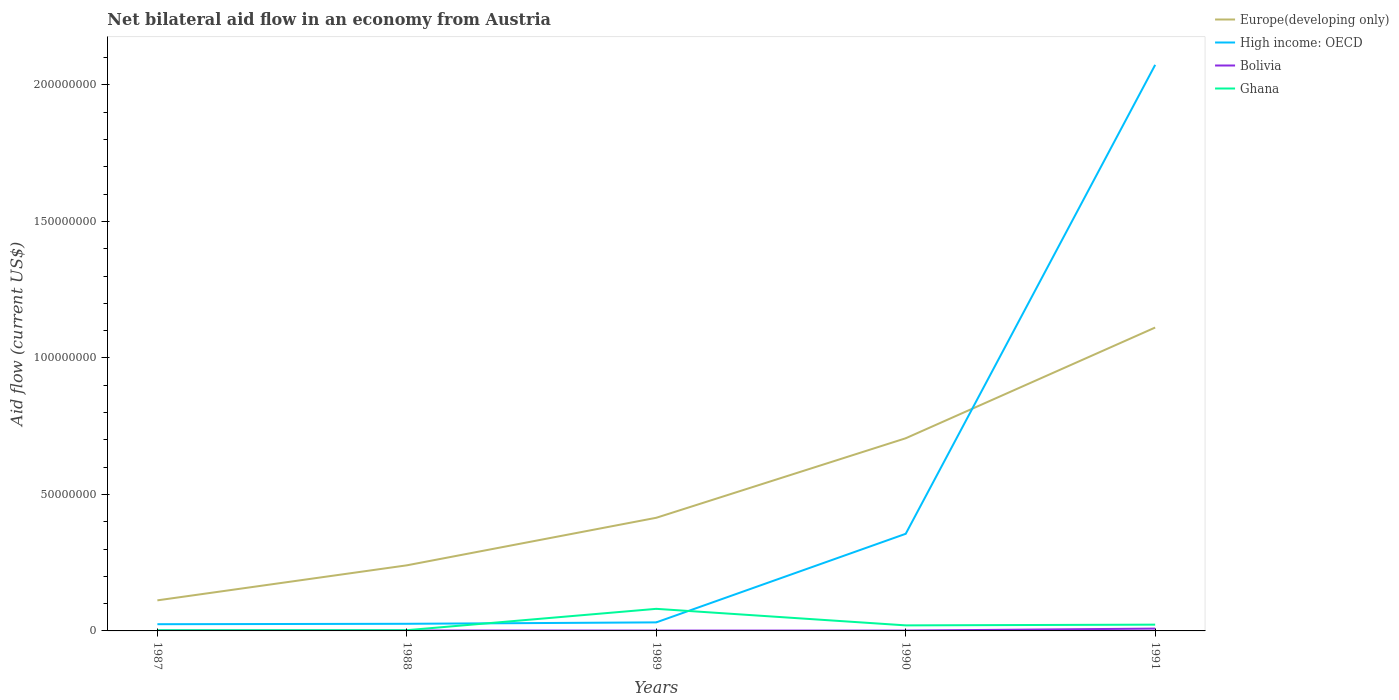Does the line corresponding to Ghana intersect with the line corresponding to Europe(developing only)?
Ensure brevity in your answer.  No. Is the number of lines equal to the number of legend labels?
Provide a succinct answer. Yes. Across all years, what is the maximum net bilateral aid flow in Bolivia?
Provide a succinct answer. 1.30e+05. In which year was the net bilateral aid flow in Bolivia maximum?
Keep it short and to the point. 1989. What is the total net bilateral aid flow in Bolivia in the graph?
Make the answer very short. -7.20e+05. What is the difference between the highest and the second highest net bilateral aid flow in Europe(developing only)?
Your answer should be very brief. 9.99e+07. How many lines are there?
Ensure brevity in your answer.  4. How many years are there in the graph?
Keep it short and to the point. 5. Does the graph contain any zero values?
Give a very brief answer. No. Does the graph contain grids?
Your answer should be compact. No. Where does the legend appear in the graph?
Give a very brief answer. Top right. How many legend labels are there?
Your answer should be compact. 4. How are the legend labels stacked?
Your answer should be very brief. Vertical. What is the title of the graph?
Your response must be concise. Net bilateral aid flow in an economy from Austria. Does "Russian Federation" appear as one of the legend labels in the graph?
Make the answer very short. No. What is the label or title of the X-axis?
Your answer should be very brief. Years. What is the Aid flow (current US$) of Europe(developing only) in 1987?
Make the answer very short. 1.12e+07. What is the Aid flow (current US$) in High income: OECD in 1987?
Provide a succinct answer. 2.46e+06. What is the Aid flow (current US$) in Europe(developing only) in 1988?
Offer a terse response. 2.40e+07. What is the Aid flow (current US$) in High income: OECD in 1988?
Your answer should be compact. 2.61e+06. What is the Aid flow (current US$) of Bolivia in 1988?
Provide a succinct answer. 1.60e+05. What is the Aid flow (current US$) in Europe(developing only) in 1989?
Provide a succinct answer. 4.14e+07. What is the Aid flow (current US$) of High income: OECD in 1989?
Give a very brief answer. 3.13e+06. What is the Aid flow (current US$) of Bolivia in 1989?
Your answer should be compact. 1.30e+05. What is the Aid flow (current US$) of Ghana in 1989?
Your response must be concise. 8.09e+06. What is the Aid flow (current US$) of Europe(developing only) in 1990?
Keep it short and to the point. 7.06e+07. What is the Aid flow (current US$) of High income: OECD in 1990?
Keep it short and to the point. 3.56e+07. What is the Aid flow (current US$) of Bolivia in 1990?
Keep it short and to the point. 1.30e+05. What is the Aid flow (current US$) in Ghana in 1990?
Your answer should be very brief. 2.03e+06. What is the Aid flow (current US$) in Europe(developing only) in 1991?
Give a very brief answer. 1.11e+08. What is the Aid flow (current US$) in High income: OECD in 1991?
Your answer should be very brief. 2.07e+08. What is the Aid flow (current US$) in Bolivia in 1991?
Provide a short and direct response. 8.50e+05. What is the Aid flow (current US$) of Ghana in 1991?
Keep it short and to the point. 2.30e+06. Across all years, what is the maximum Aid flow (current US$) in Europe(developing only)?
Offer a terse response. 1.11e+08. Across all years, what is the maximum Aid flow (current US$) of High income: OECD?
Provide a short and direct response. 2.07e+08. Across all years, what is the maximum Aid flow (current US$) of Bolivia?
Ensure brevity in your answer.  8.50e+05. Across all years, what is the maximum Aid flow (current US$) in Ghana?
Make the answer very short. 8.09e+06. Across all years, what is the minimum Aid flow (current US$) in Europe(developing only)?
Provide a short and direct response. 1.12e+07. Across all years, what is the minimum Aid flow (current US$) of High income: OECD?
Make the answer very short. 2.46e+06. What is the total Aid flow (current US$) of Europe(developing only) in the graph?
Your answer should be compact. 2.58e+08. What is the total Aid flow (current US$) of High income: OECD in the graph?
Your response must be concise. 2.51e+08. What is the total Aid flow (current US$) of Bolivia in the graph?
Give a very brief answer. 1.41e+06. What is the total Aid flow (current US$) of Ghana in the graph?
Give a very brief answer. 1.29e+07. What is the difference between the Aid flow (current US$) of Europe(developing only) in 1987 and that in 1988?
Provide a succinct answer. -1.28e+07. What is the difference between the Aid flow (current US$) of Europe(developing only) in 1987 and that in 1989?
Offer a terse response. -3.02e+07. What is the difference between the Aid flow (current US$) in High income: OECD in 1987 and that in 1989?
Your response must be concise. -6.70e+05. What is the difference between the Aid flow (current US$) of Bolivia in 1987 and that in 1989?
Make the answer very short. 10000. What is the difference between the Aid flow (current US$) in Ghana in 1987 and that in 1989?
Your answer should be compact. -7.84e+06. What is the difference between the Aid flow (current US$) in Europe(developing only) in 1987 and that in 1990?
Make the answer very short. -5.94e+07. What is the difference between the Aid flow (current US$) of High income: OECD in 1987 and that in 1990?
Offer a very short reply. -3.31e+07. What is the difference between the Aid flow (current US$) of Bolivia in 1987 and that in 1990?
Make the answer very short. 10000. What is the difference between the Aid flow (current US$) in Ghana in 1987 and that in 1990?
Give a very brief answer. -1.78e+06. What is the difference between the Aid flow (current US$) of Europe(developing only) in 1987 and that in 1991?
Your answer should be very brief. -9.99e+07. What is the difference between the Aid flow (current US$) in High income: OECD in 1987 and that in 1991?
Keep it short and to the point. -2.05e+08. What is the difference between the Aid flow (current US$) in Bolivia in 1987 and that in 1991?
Offer a terse response. -7.10e+05. What is the difference between the Aid flow (current US$) of Ghana in 1987 and that in 1991?
Your response must be concise. -2.05e+06. What is the difference between the Aid flow (current US$) of Europe(developing only) in 1988 and that in 1989?
Your response must be concise. -1.74e+07. What is the difference between the Aid flow (current US$) in High income: OECD in 1988 and that in 1989?
Provide a succinct answer. -5.20e+05. What is the difference between the Aid flow (current US$) of Bolivia in 1988 and that in 1989?
Your answer should be compact. 3.00e+04. What is the difference between the Aid flow (current US$) of Ghana in 1988 and that in 1989?
Your response must be concise. -7.82e+06. What is the difference between the Aid flow (current US$) in Europe(developing only) in 1988 and that in 1990?
Keep it short and to the point. -4.66e+07. What is the difference between the Aid flow (current US$) in High income: OECD in 1988 and that in 1990?
Make the answer very short. -3.30e+07. What is the difference between the Aid flow (current US$) in Ghana in 1988 and that in 1990?
Offer a very short reply. -1.76e+06. What is the difference between the Aid flow (current US$) of Europe(developing only) in 1988 and that in 1991?
Your response must be concise. -8.71e+07. What is the difference between the Aid flow (current US$) in High income: OECD in 1988 and that in 1991?
Offer a terse response. -2.05e+08. What is the difference between the Aid flow (current US$) in Bolivia in 1988 and that in 1991?
Provide a short and direct response. -6.90e+05. What is the difference between the Aid flow (current US$) in Ghana in 1988 and that in 1991?
Offer a terse response. -2.03e+06. What is the difference between the Aid flow (current US$) of Europe(developing only) in 1989 and that in 1990?
Give a very brief answer. -2.91e+07. What is the difference between the Aid flow (current US$) of High income: OECD in 1989 and that in 1990?
Ensure brevity in your answer.  -3.24e+07. What is the difference between the Aid flow (current US$) of Ghana in 1989 and that in 1990?
Your answer should be very brief. 6.06e+06. What is the difference between the Aid flow (current US$) of Europe(developing only) in 1989 and that in 1991?
Ensure brevity in your answer.  -6.97e+07. What is the difference between the Aid flow (current US$) in High income: OECD in 1989 and that in 1991?
Offer a terse response. -2.04e+08. What is the difference between the Aid flow (current US$) of Bolivia in 1989 and that in 1991?
Offer a terse response. -7.20e+05. What is the difference between the Aid flow (current US$) in Ghana in 1989 and that in 1991?
Your answer should be compact. 5.79e+06. What is the difference between the Aid flow (current US$) in Europe(developing only) in 1990 and that in 1991?
Your response must be concise. -4.06e+07. What is the difference between the Aid flow (current US$) in High income: OECD in 1990 and that in 1991?
Give a very brief answer. -1.72e+08. What is the difference between the Aid flow (current US$) of Bolivia in 1990 and that in 1991?
Give a very brief answer. -7.20e+05. What is the difference between the Aid flow (current US$) in Europe(developing only) in 1987 and the Aid flow (current US$) in High income: OECD in 1988?
Offer a terse response. 8.59e+06. What is the difference between the Aid flow (current US$) of Europe(developing only) in 1987 and the Aid flow (current US$) of Bolivia in 1988?
Keep it short and to the point. 1.10e+07. What is the difference between the Aid flow (current US$) in Europe(developing only) in 1987 and the Aid flow (current US$) in Ghana in 1988?
Provide a short and direct response. 1.09e+07. What is the difference between the Aid flow (current US$) in High income: OECD in 1987 and the Aid flow (current US$) in Bolivia in 1988?
Your response must be concise. 2.30e+06. What is the difference between the Aid flow (current US$) of High income: OECD in 1987 and the Aid flow (current US$) of Ghana in 1988?
Provide a short and direct response. 2.19e+06. What is the difference between the Aid flow (current US$) of Bolivia in 1987 and the Aid flow (current US$) of Ghana in 1988?
Provide a short and direct response. -1.30e+05. What is the difference between the Aid flow (current US$) in Europe(developing only) in 1987 and the Aid flow (current US$) in High income: OECD in 1989?
Provide a short and direct response. 8.07e+06. What is the difference between the Aid flow (current US$) of Europe(developing only) in 1987 and the Aid flow (current US$) of Bolivia in 1989?
Offer a very short reply. 1.11e+07. What is the difference between the Aid flow (current US$) of Europe(developing only) in 1987 and the Aid flow (current US$) of Ghana in 1989?
Give a very brief answer. 3.11e+06. What is the difference between the Aid flow (current US$) in High income: OECD in 1987 and the Aid flow (current US$) in Bolivia in 1989?
Ensure brevity in your answer.  2.33e+06. What is the difference between the Aid flow (current US$) in High income: OECD in 1987 and the Aid flow (current US$) in Ghana in 1989?
Your response must be concise. -5.63e+06. What is the difference between the Aid flow (current US$) of Bolivia in 1987 and the Aid flow (current US$) of Ghana in 1989?
Your answer should be compact. -7.95e+06. What is the difference between the Aid flow (current US$) in Europe(developing only) in 1987 and the Aid flow (current US$) in High income: OECD in 1990?
Offer a terse response. -2.44e+07. What is the difference between the Aid flow (current US$) of Europe(developing only) in 1987 and the Aid flow (current US$) of Bolivia in 1990?
Your answer should be compact. 1.11e+07. What is the difference between the Aid flow (current US$) in Europe(developing only) in 1987 and the Aid flow (current US$) in Ghana in 1990?
Ensure brevity in your answer.  9.17e+06. What is the difference between the Aid flow (current US$) of High income: OECD in 1987 and the Aid flow (current US$) of Bolivia in 1990?
Make the answer very short. 2.33e+06. What is the difference between the Aid flow (current US$) of High income: OECD in 1987 and the Aid flow (current US$) of Ghana in 1990?
Provide a succinct answer. 4.30e+05. What is the difference between the Aid flow (current US$) of Bolivia in 1987 and the Aid flow (current US$) of Ghana in 1990?
Provide a succinct answer. -1.89e+06. What is the difference between the Aid flow (current US$) of Europe(developing only) in 1987 and the Aid flow (current US$) of High income: OECD in 1991?
Your answer should be very brief. -1.96e+08. What is the difference between the Aid flow (current US$) of Europe(developing only) in 1987 and the Aid flow (current US$) of Bolivia in 1991?
Keep it short and to the point. 1.04e+07. What is the difference between the Aid flow (current US$) of Europe(developing only) in 1987 and the Aid flow (current US$) of Ghana in 1991?
Your answer should be very brief. 8.90e+06. What is the difference between the Aid flow (current US$) of High income: OECD in 1987 and the Aid flow (current US$) of Bolivia in 1991?
Ensure brevity in your answer.  1.61e+06. What is the difference between the Aid flow (current US$) of Bolivia in 1987 and the Aid flow (current US$) of Ghana in 1991?
Your response must be concise. -2.16e+06. What is the difference between the Aid flow (current US$) in Europe(developing only) in 1988 and the Aid flow (current US$) in High income: OECD in 1989?
Provide a short and direct response. 2.09e+07. What is the difference between the Aid flow (current US$) in Europe(developing only) in 1988 and the Aid flow (current US$) in Bolivia in 1989?
Offer a terse response. 2.39e+07. What is the difference between the Aid flow (current US$) of Europe(developing only) in 1988 and the Aid flow (current US$) of Ghana in 1989?
Keep it short and to the point. 1.59e+07. What is the difference between the Aid flow (current US$) of High income: OECD in 1988 and the Aid flow (current US$) of Bolivia in 1989?
Your response must be concise. 2.48e+06. What is the difference between the Aid flow (current US$) in High income: OECD in 1988 and the Aid flow (current US$) in Ghana in 1989?
Keep it short and to the point. -5.48e+06. What is the difference between the Aid flow (current US$) in Bolivia in 1988 and the Aid flow (current US$) in Ghana in 1989?
Offer a very short reply. -7.93e+06. What is the difference between the Aid flow (current US$) in Europe(developing only) in 1988 and the Aid flow (current US$) in High income: OECD in 1990?
Provide a succinct answer. -1.16e+07. What is the difference between the Aid flow (current US$) in Europe(developing only) in 1988 and the Aid flow (current US$) in Bolivia in 1990?
Provide a succinct answer. 2.39e+07. What is the difference between the Aid flow (current US$) in Europe(developing only) in 1988 and the Aid flow (current US$) in Ghana in 1990?
Make the answer very short. 2.20e+07. What is the difference between the Aid flow (current US$) of High income: OECD in 1988 and the Aid flow (current US$) of Bolivia in 1990?
Make the answer very short. 2.48e+06. What is the difference between the Aid flow (current US$) in High income: OECD in 1988 and the Aid flow (current US$) in Ghana in 1990?
Give a very brief answer. 5.80e+05. What is the difference between the Aid flow (current US$) of Bolivia in 1988 and the Aid flow (current US$) of Ghana in 1990?
Your answer should be very brief. -1.87e+06. What is the difference between the Aid flow (current US$) in Europe(developing only) in 1988 and the Aid flow (current US$) in High income: OECD in 1991?
Your response must be concise. -1.83e+08. What is the difference between the Aid flow (current US$) of Europe(developing only) in 1988 and the Aid flow (current US$) of Bolivia in 1991?
Your response must be concise. 2.32e+07. What is the difference between the Aid flow (current US$) of Europe(developing only) in 1988 and the Aid flow (current US$) of Ghana in 1991?
Your response must be concise. 2.17e+07. What is the difference between the Aid flow (current US$) in High income: OECD in 1988 and the Aid flow (current US$) in Bolivia in 1991?
Your response must be concise. 1.76e+06. What is the difference between the Aid flow (current US$) of High income: OECD in 1988 and the Aid flow (current US$) of Ghana in 1991?
Keep it short and to the point. 3.10e+05. What is the difference between the Aid flow (current US$) in Bolivia in 1988 and the Aid flow (current US$) in Ghana in 1991?
Provide a succinct answer. -2.14e+06. What is the difference between the Aid flow (current US$) of Europe(developing only) in 1989 and the Aid flow (current US$) of High income: OECD in 1990?
Provide a succinct answer. 5.87e+06. What is the difference between the Aid flow (current US$) in Europe(developing only) in 1989 and the Aid flow (current US$) in Bolivia in 1990?
Offer a very short reply. 4.13e+07. What is the difference between the Aid flow (current US$) of Europe(developing only) in 1989 and the Aid flow (current US$) of Ghana in 1990?
Provide a short and direct response. 3.94e+07. What is the difference between the Aid flow (current US$) in High income: OECD in 1989 and the Aid flow (current US$) in Bolivia in 1990?
Offer a very short reply. 3.00e+06. What is the difference between the Aid flow (current US$) of High income: OECD in 1989 and the Aid flow (current US$) of Ghana in 1990?
Keep it short and to the point. 1.10e+06. What is the difference between the Aid flow (current US$) of Bolivia in 1989 and the Aid flow (current US$) of Ghana in 1990?
Keep it short and to the point. -1.90e+06. What is the difference between the Aid flow (current US$) of Europe(developing only) in 1989 and the Aid flow (current US$) of High income: OECD in 1991?
Your answer should be compact. -1.66e+08. What is the difference between the Aid flow (current US$) of Europe(developing only) in 1989 and the Aid flow (current US$) of Bolivia in 1991?
Make the answer very short. 4.06e+07. What is the difference between the Aid flow (current US$) in Europe(developing only) in 1989 and the Aid flow (current US$) in Ghana in 1991?
Give a very brief answer. 3.92e+07. What is the difference between the Aid flow (current US$) of High income: OECD in 1989 and the Aid flow (current US$) of Bolivia in 1991?
Keep it short and to the point. 2.28e+06. What is the difference between the Aid flow (current US$) of High income: OECD in 1989 and the Aid flow (current US$) of Ghana in 1991?
Your response must be concise. 8.30e+05. What is the difference between the Aid flow (current US$) of Bolivia in 1989 and the Aid flow (current US$) of Ghana in 1991?
Provide a succinct answer. -2.17e+06. What is the difference between the Aid flow (current US$) of Europe(developing only) in 1990 and the Aid flow (current US$) of High income: OECD in 1991?
Keep it short and to the point. -1.37e+08. What is the difference between the Aid flow (current US$) of Europe(developing only) in 1990 and the Aid flow (current US$) of Bolivia in 1991?
Provide a short and direct response. 6.97e+07. What is the difference between the Aid flow (current US$) of Europe(developing only) in 1990 and the Aid flow (current US$) of Ghana in 1991?
Offer a terse response. 6.83e+07. What is the difference between the Aid flow (current US$) of High income: OECD in 1990 and the Aid flow (current US$) of Bolivia in 1991?
Your answer should be compact. 3.47e+07. What is the difference between the Aid flow (current US$) of High income: OECD in 1990 and the Aid flow (current US$) of Ghana in 1991?
Give a very brief answer. 3.33e+07. What is the difference between the Aid flow (current US$) in Bolivia in 1990 and the Aid flow (current US$) in Ghana in 1991?
Give a very brief answer. -2.17e+06. What is the average Aid flow (current US$) in Europe(developing only) per year?
Your response must be concise. 5.17e+07. What is the average Aid flow (current US$) in High income: OECD per year?
Offer a very short reply. 5.02e+07. What is the average Aid flow (current US$) of Bolivia per year?
Give a very brief answer. 2.82e+05. What is the average Aid flow (current US$) in Ghana per year?
Your answer should be very brief. 2.59e+06. In the year 1987, what is the difference between the Aid flow (current US$) of Europe(developing only) and Aid flow (current US$) of High income: OECD?
Your answer should be compact. 8.74e+06. In the year 1987, what is the difference between the Aid flow (current US$) of Europe(developing only) and Aid flow (current US$) of Bolivia?
Your answer should be compact. 1.11e+07. In the year 1987, what is the difference between the Aid flow (current US$) of Europe(developing only) and Aid flow (current US$) of Ghana?
Ensure brevity in your answer.  1.10e+07. In the year 1987, what is the difference between the Aid flow (current US$) in High income: OECD and Aid flow (current US$) in Bolivia?
Ensure brevity in your answer.  2.32e+06. In the year 1987, what is the difference between the Aid flow (current US$) in High income: OECD and Aid flow (current US$) in Ghana?
Your answer should be compact. 2.21e+06. In the year 1987, what is the difference between the Aid flow (current US$) of Bolivia and Aid flow (current US$) of Ghana?
Make the answer very short. -1.10e+05. In the year 1988, what is the difference between the Aid flow (current US$) of Europe(developing only) and Aid flow (current US$) of High income: OECD?
Ensure brevity in your answer.  2.14e+07. In the year 1988, what is the difference between the Aid flow (current US$) of Europe(developing only) and Aid flow (current US$) of Bolivia?
Provide a short and direct response. 2.39e+07. In the year 1988, what is the difference between the Aid flow (current US$) of Europe(developing only) and Aid flow (current US$) of Ghana?
Ensure brevity in your answer.  2.38e+07. In the year 1988, what is the difference between the Aid flow (current US$) of High income: OECD and Aid flow (current US$) of Bolivia?
Your answer should be very brief. 2.45e+06. In the year 1988, what is the difference between the Aid flow (current US$) in High income: OECD and Aid flow (current US$) in Ghana?
Provide a succinct answer. 2.34e+06. In the year 1988, what is the difference between the Aid flow (current US$) in Bolivia and Aid flow (current US$) in Ghana?
Your response must be concise. -1.10e+05. In the year 1989, what is the difference between the Aid flow (current US$) in Europe(developing only) and Aid flow (current US$) in High income: OECD?
Offer a terse response. 3.83e+07. In the year 1989, what is the difference between the Aid flow (current US$) of Europe(developing only) and Aid flow (current US$) of Bolivia?
Give a very brief answer. 4.13e+07. In the year 1989, what is the difference between the Aid flow (current US$) in Europe(developing only) and Aid flow (current US$) in Ghana?
Make the answer very short. 3.34e+07. In the year 1989, what is the difference between the Aid flow (current US$) of High income: OECD and Aid flow (current US$) of Ghana?
Make the answer very short. -4.96e+06. In the year 1989, what is the difference between the Aid flow (current US$) in Bolivia and Aid flow (current US$) in Ghana?
Keep it short and to the point. -7.96e+06. In the year 1990, what is the difference between the Aid flow (current US$) in Europe(developing only) and Aid flow (current US$) in High income: OECD?
Provide a succinct answer. 3.50e+07. In the year 1990, what is the difference between the Aid flow (current US$) of Europe(developing only) and Aid flow (current US$) of Bolivia?
Make the answer very short. 7.04e+07. In the year 1990, what is the difference between the Aid flow (current US$) in Europe(developing only) and Aid flow (current US$) in Ghana?
Make the answer very short. 6.86e+07. In the year 1990, what is the difference between the Aid flow (current US$) in High income: OECD and Aid flow (current US$) in Bolivia?
Make the answer very short. 3.54e+07. In the year 1990, what is the difference between the Aid flow (current US$) of High income: OECD and Aid flow (current US$) of Ghana?
Offer a terse response. 3.36e+07. In the year 1990, what is the difference between the Aid flow (current US$) of Bolivia and Aid flow (current US$) of Ghana?
Your answer should be very brief. -1.90e+06. In the year 1991, what is the difference between the Aid flow (current US$) of Europe(developing only) and Aid flow (current US$) of High income: OECD?
Give a very brief answer. -9.62e+07. In the year 1991, what is the difference between the Aid flow (current US$) in Europe(developing only) and Aid flow (current US$) in Bolivia?
Provide a succinct answer. 1.10e+08. In the year 1991, what is the difference between the Aid flow (current US$) in Europe(developing only) and Aid flow (current US$) in Ghana?
Ensure brevity in your answer.  1.09e+08. In the year 1991, what is the difference between the Aid flow (current US$) of High income: OECD and Aid flow (current US$) of Bolivia?
Provide a short and direct response. 2.07e+08. In the year 1991, what is the difference between the Aid flow (current US$) of High income: OECD and Aid flow (current US$) of Ghana?
Ensure brevity in your answer.  2.05e+08. In the year 1991, what is the difference between the Aid flow (current US$) in Bolivia and Aid flow (current US$) in Ghana?
Your answer should be compact. -1.45e+06. What is the ratio of the Aid flow (current US$) in Europe(developing only) in 1987 to that in 1988?
Ensure brevity in your answer.  0.47. What is the ratio of the Aid flow (current US$) in High income: OECD in 1987 to that in 1988?
Provide a succinct answer. 0.94. What is the ratio of the Aid flow (current US$) of Ghana in 1987 to that in 1988?
Offer a terse response. 0.93. What is the ratio of the Aid flow (current US$) of Europe(developing only) in 1987 to that in 1989?
Offer a terse response. 0.27. What is the ratio of the Aid flow (current US$) in High income: OECD in 1987 to that in 1989?
Offer a terse response. 0.79. What is the ratio of the Aid flow (current US$) of Ghana in 1987 to that in 1989?
Ensure brevity in your answer.  0.03. What is the ratio of the Aid flow (current US$) in Europe(developing only) in 1987 to that in 1990?
Keep it short and to the point. 0.16. What is the ratio of the Aid flow (current US$) of High income: OECD in 1987 to that in 1990?
Your answer should be very brief. 0.07. What is the ratio of the Aid flow (current US$) of Ghana in 1987 to that in 1990?
Give a very brief answer. 0.12. What is the ratio of the Aid flow (current US$) in Europe(developing only) in 1987 to that in 1991?
Your answer should be very brief. 0.1. What is the ratio of the Aid flow (current US$) of High income: OECD in 1987 to that in 1991?
Make the answer very short. 0.01. What is the ratio of the Aid flow (current US$) in Bolivia in 1987 to that in 1991?
Give a very brief answer. 0.16. What is the ratio of the Aid flow (current US$) of Ghana in 1987 to that in 1991?
Your answer should be very brief. 0.11. What is the ratio of the Aid flow (current US$) in Europe(developing only) in 1988 to that in 1989?
Your answer should be compact. 0.58. What is the ratio of the Aid flow (current US$) in High income: OECD in 1988 to that in 1989?
Your answer should be compact. 0.83. What is the ratio of the Aid flow (current US$) of Bolivia in 1988 to that in 1989?
Make the answer very short. 1.23. What is the ratio of the Aid flow (current US$) in Ghana in 1988 to that in 1989?
Offer a very short reply. 0.03. What is the ratio of the Aid flow (current US$) of Europe(developing only) in 1988 to that in 1990?
Provide a short and direct response. 0.34. What is the ratio of the Aid flow (current US$) of High income: OECD in 1988 to that in 1990?
Offer a terse response. 0.07. What is the ratio of the Aid flow (current US$) in Bolivia in 1988 to that in 1990?
Your answer should be compact. 1.23. What is the ratio of the Aid flow (current US$) in Ghana in 1988 to that in 1990?
Your answer should be compact. 0.13. What is the ratio of the Aid flow (current US$) of Europe(developing only) in 1988 to that in 1991?
Your answer should be compact. 0.22. What is the ratio of the Aid flow (current US$) of High income: OECD in 1988 to that in 1991?
Your answer should be compact. 0.01. What is the ratio of the Aid flow (current US$) in Bolivia in 1988 to that in 1991?
Keep it short and to the point. 0.19. What is the ratio of the Aid flow (current US$) in Ghana in 1988 to that in 1991?
Your answer should be very brief. 0.12. What is the ratio of the Aid flow (current US$) of Europe(developing only) in 1989 to that in 1990?
Your answer should be compact. 0.59. What is the ratio of the Aid flow (current US$) in High income: OECD in 1989 to that in 1990?
Offer a very short reply. 0.09. What is the ratio of the Aid flow (current US$) of Ghana in 1989 to that in 1990?
Ensure brevity in your answer.  3.99. What is the ratio of the Aid flow (current US$) of Europe(developing only) in 1989 to that in 1991?
Provide a short and direct response. 0.37. What is the ratio of the Aid flow (current US$) of High income: OECD in 1989 to that in 1991?
Offer a very short reply. 0.02. What is the ratio of the Aid flow (current US$) in Bolivia in 1989 to that in 1991?
Your answer should be compact. 0.15. What is the ratio of the Aid flow (current US$) in Ghana in 1989 to that in 1991?
Keep it short and to the point. 3.52. What is the ratio of the Aid flow (current US$) of Europe(developing only) in 1990 to that in 1991?
Provide a short and direct response. 0.64. What is the ratio of the Aid flow (current US$) of High income: OECD in 1990 to that in 1991?
Ensure brevity in your answer.  0.17. What is the ratio of the Aid flow (current US$) of Bolivia in 1990 to that in 1991?
Make the answer very short. 0.15. What is the ratio of the Aid flow (current US$) in Ghana in 1990 to that in 1991?
Offer a very short reply. 0.88. What is the difference between the highest and the second highest Aid flow (current US$) of Europe(developing only)?
Make the answer very short. 4.06e+07. What is the difference between the highest and the second highest Aid flow (current US$) in High income: OECD?
Provide a short and direct response. 1.72e+08. What is the difference between the highest and the second highest Aid flow (current US$) in Bolivia?
Your response must be concise. 6.90e+05. What is the difference between the highest and the second highest Aid flow (current US$) of Ghana?
Provide a short and direct response. 5.79e+06. What is the difference between the highest and the lowest Aid flow (current US$) in Europe(developing only)?
Provide a short and direct response. 9.99e+07. What is the difference between the highest and the lowest Aid flow (current US$) of High income: OECD?
Your response must be concise. 2.05e+08. What is the difference between the highest and the lowest Aid flow (current US$) in Bolivia?
Ensure brevity in your answer.  7.20e+05. What is the difference between the highest and the lowest Aid flow (current US$) in Ghana?
Make the answer very short. 7.84e+06. 